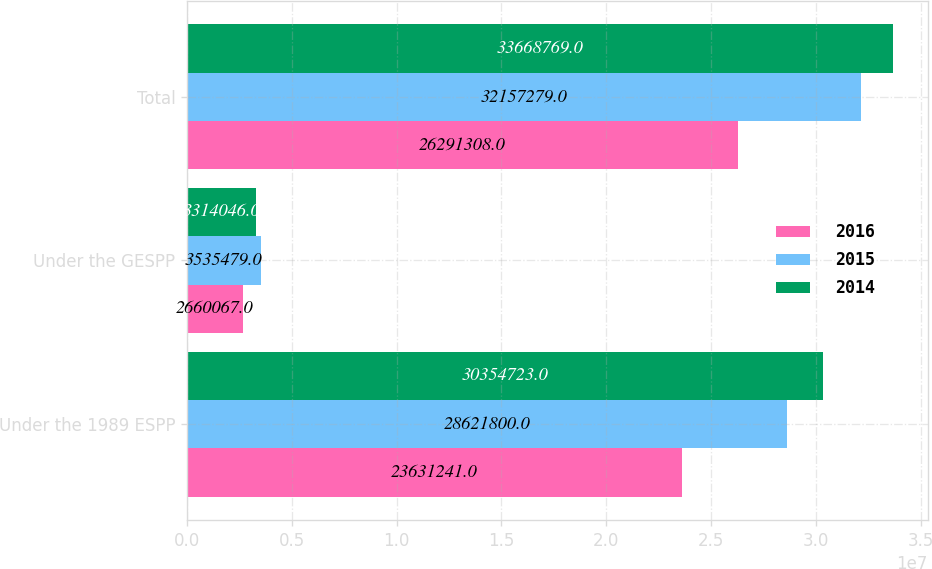Convert chart. <chart><loc_0><loc_0><loc_500><loc_500><stacked_bar_chart><ecel><fcel>Under the 1989 ESPP<fcel>Under the GESPP<fcel>Total<nl><fcel>2016<fcel>2.36312e+07<fcel>2.66007e+06<fcel>2.62913e+07<nl><fcel>2015<fcel>2.86218e+07<fcel>3.53548e+06<fcel>3.21573e+07<nl><fcel>2014<fcel>3.03547e+07<fcel>3.31405e+06<fcel>3.36688e+07<nl></chart> 